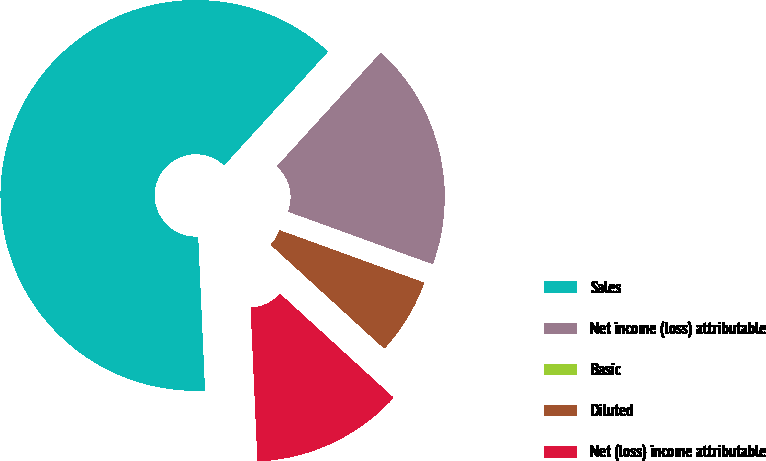<chart> <loc_0><loc_0><loc_500><loc_500><pie_chart><fcel>Sales<fcel>Net income (loss) attributable<fcel>Basic<fcel>Diluted<fcel>Net (loss) income attributable<nl><fcel>62.5%<fcel>18.75%<fcel>0.0%<fcel>6.25%<fcel>12.5%<nl></chart> 